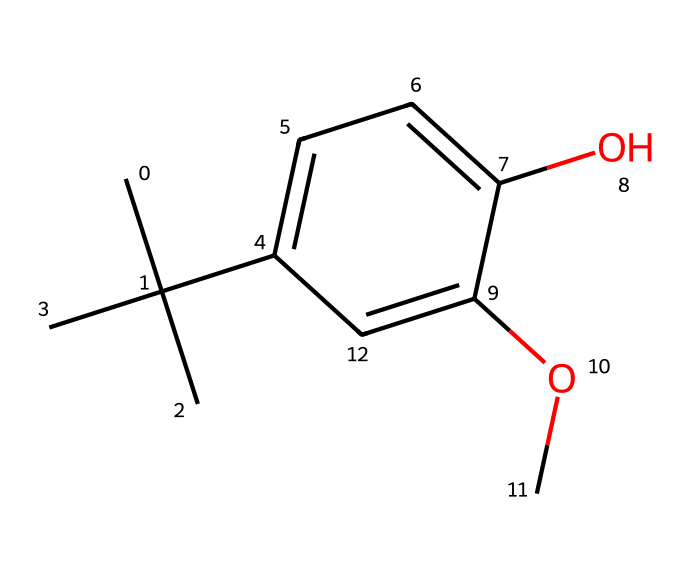How many carbon atoms are present in this structure? By analyzing the SMILES representation, we can count the carbon atoms in the structure. The representation indicates a total of 10 carbon atoms, counting each "C" and understanding the branching.
Answer: 10 What type of functional groups are present in this molecule? Looking at the structure, we can identify the functional groups: a hydroxyl group (–OH) and a methoxy group (–OCH3), which influence its chemical properties.
Answer: hydroxyl and methoxy How many aromatic rings are in this compound? The structure exhibits one aromatic ring indicated by "c" in the SMILES notation, which signifies the presence of a benzene-like structure.
Answer: 1 What is the main purpose of butylated hydroxyanisole (BHA) in food products? BHA is primarily used as a preservative to prevent oxidation in fats and oils, thus extending the shelf life of food products.
Answer: preservative What is the degree of unsaturation in this molecule? The degree of unsaturation can be calculated using the formula (1 + C - H/2). For this molecule, it results in 4, primarily due to the presence of the aromatic ring and the double bonds in the structure.
Answer: 4 